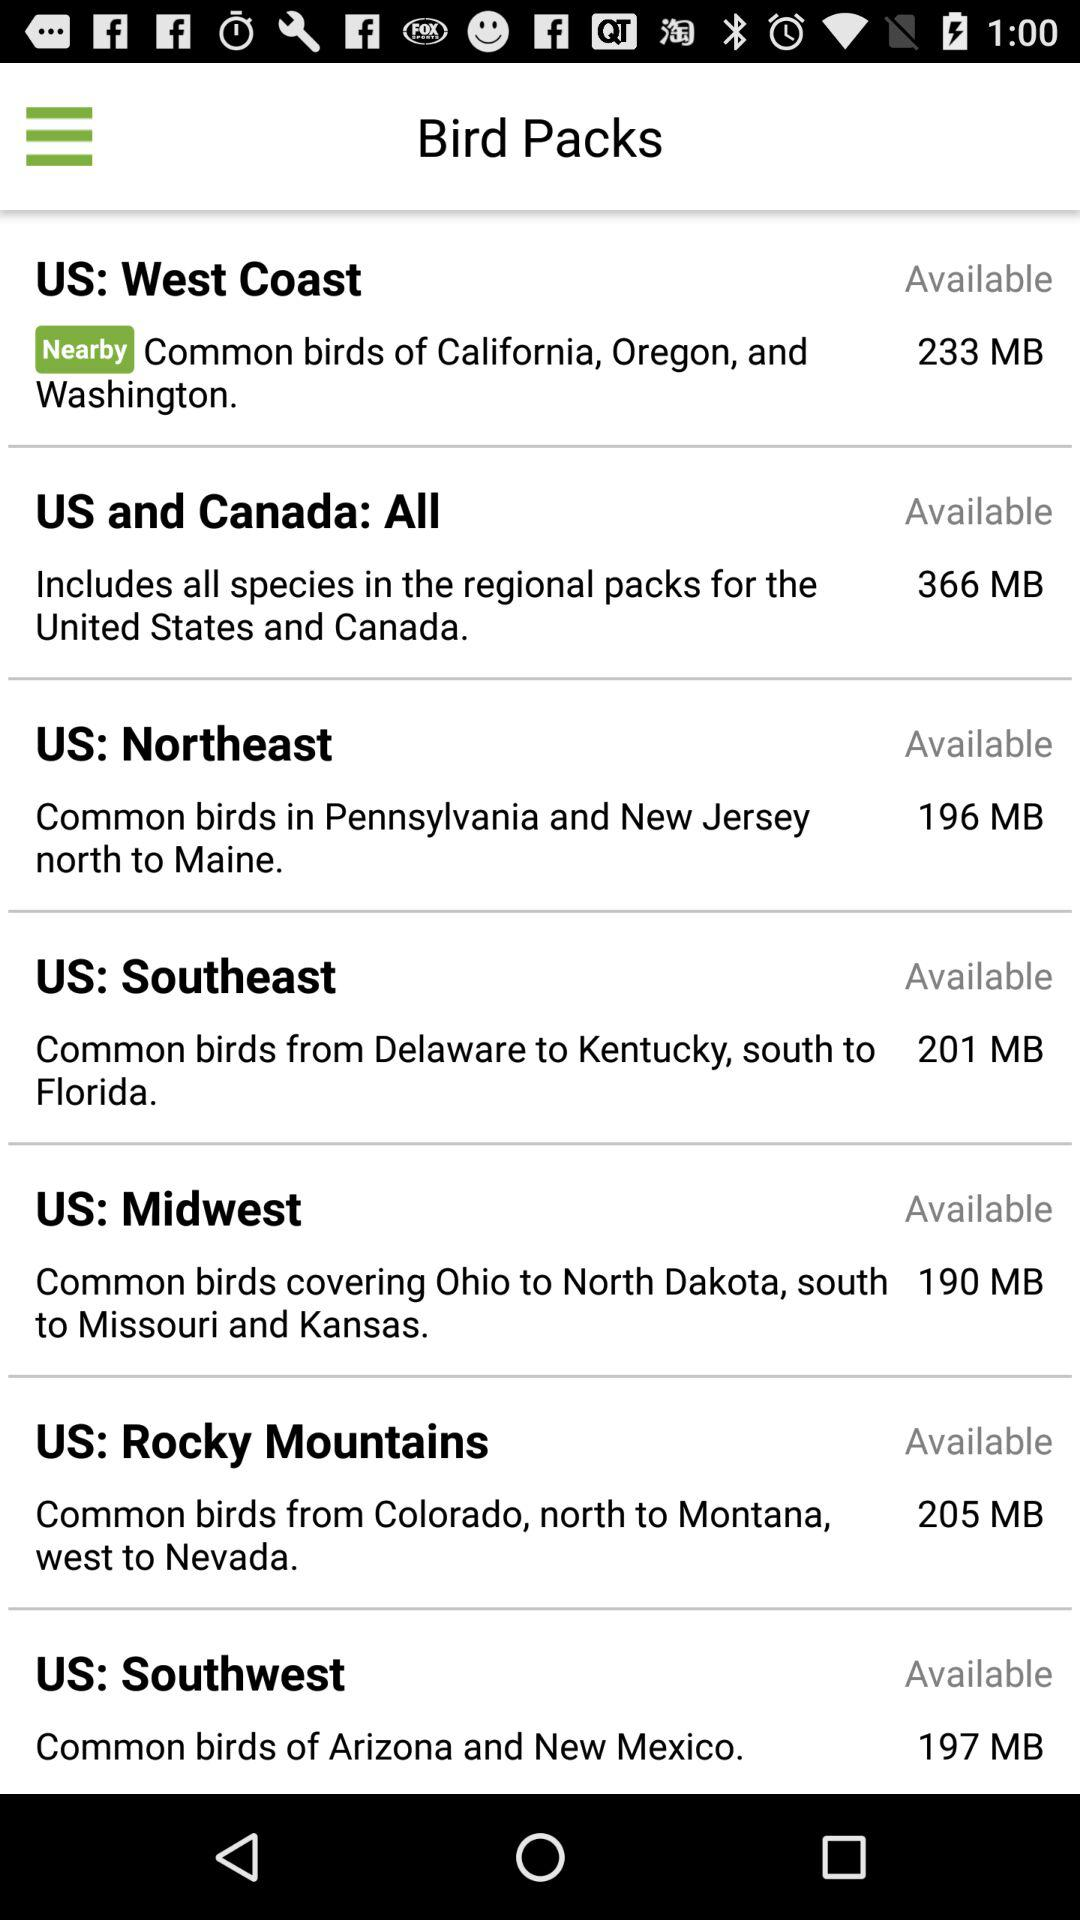Which US region do common birds in Pennsylvania and New Jersey belong to? The US region is the Northeast. 